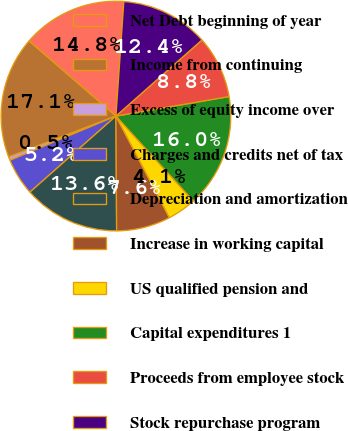Convert chart. <chart><loc_0><loc_0><loc_500><loc_500><pie_chart><fcel>Net Debt beginning of year<fcel>Income from continuing<fcel>Excess of equity income over<fcel>Charges and credits net of tax<fcel>Depreciation and amortization<fcel>Increase in working capital<fcel>US qualified pension and<fcel>Capital expenditures 1<fcel>Proceeds from employee stock<fcel>Stock repurchase program<nl><fcel>14.76%<fcel>17.14%<fcel>0.48%<fcel>5.24%<fcel>13.57%<fcel>7.62%<fcel>4.05%<fcel>15.95%<fcel>8.81%<fcel>12.38%<nl></chart> 